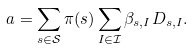Convert formula to latex. <formula><loc_0><loc_0><loc_500><loc_500>a = \sum _ { s \in \mathcal { S } } \pi ( s ) \sum _ { I \in \mathcal { I } } \beta _ { s , I } D _ { s , I } .</formula> 